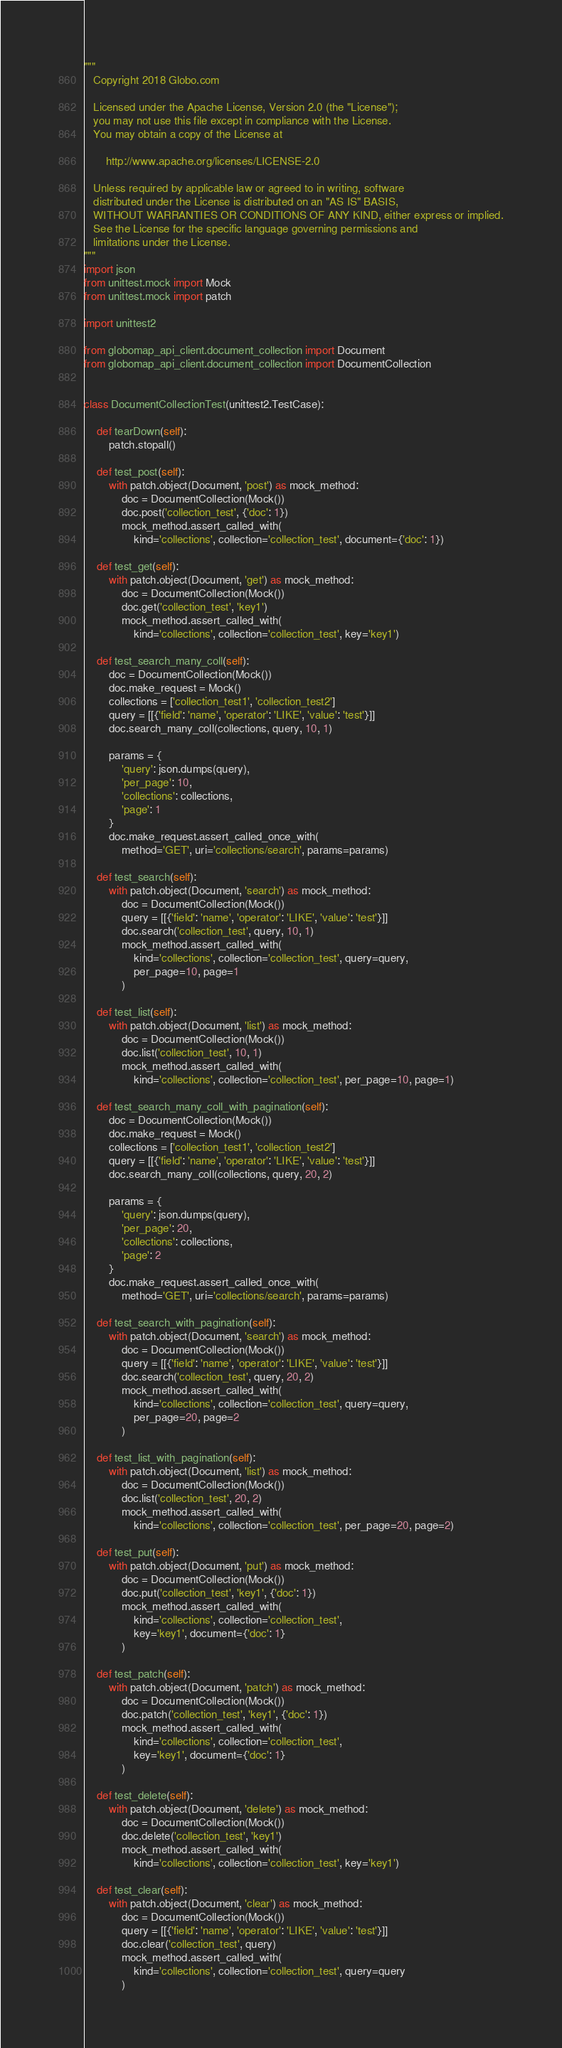Convert code to text. <code><loc_0><loc_0><loc_500><loc_500><_Python_>"""
   Copyright 2018 Globo.com

   Licensed under the Apache License, Version 2.0 (the "License");
   you may not use this file except in compliance with the License.
   You may obtain a copy of the License at

       http://www.apache.org/licenses/LICENSE-2.0

   Unless required by applicable law or agreed to in writing, software
   distributed under the License is distributed on an "AS IS" BASIS,
   WITHOUT WARRANTIES OR CONDITIONS OF ANY KIND, either express or implied.
   See the License for the specific language governing permissions and
   limitations under the License.
"""
import json
from unittest.mock import Mock
from unittest.mock import patch

import unittest2

from globomap_api_client.document_collection import Document
from globomap_api_client.document_collection import DocumentCollection


class DocumentCollectionTest(unittest2.TestCase):

    def tearDown(self):
        patch.stopall()

    def test_post(self):
        with patch.object(Document, 'post') as mock_method:
            doc = DocumentCollection(Mock())
            doc.post('collection_test', {'doc': 1})
            mock_method.assert_called_with(
                kind='collections', collection='collection_test', document={'doc': 1})

    def test_get(self):
        with patch.object(Document, 'get') as mock_method:
            doc = DocumentCollection(Mock())
            doc.get('collection_test', 'key1')
            mock_method.assert_called_with(
                kind='collections', collection='collection_test', key='key1')

    def test_search_many_coll(self):
        doc = DocumentCollection(Mock())
        doc.make_request = Mock()
        collections = ['collection_test1', 'collection_test2']
        query = [[{'field': 'name', 'operator': 'LIKE', 'value': 'test'}]]
        doc.search_many_coll(collections, query, 10, 1)

        params = {
            'query': json.dumps(query),
            'per_page': 10,
            'collections': collections,
            'page': 1
        }
        doc.make_request.assert_called_once_with(
            method='GET', uri='collections/search', params=params)

    def test_search(self):
        with patch.object(Document, 'search') as mock_method:
            doc = DocumentCollection(Mock())
            query = [[{'field': 'name', 'operator': 'LIKE', 'value': 'test'}]]
            doc.search('collection_test', query, 10, 1)
            mock_method.assert_called_with(
                kind='collections', collection='collection_test', query=query,
                per_page=10, page=1
            )

    def test_list(self):
        with patch.object(Document, 'list') as mock_method:
            doc = DocumentCollection(Mock())
            doc.list('collection_test', 10, 1)
            mock_method.assert_called_with(
                kind='collections', collection='collection_test', per_page=10, page=1)

    def test_search_many_coll_with_pagination(self):
        doc = DocumentCollection(Mock())
        doc.make_request = Mock()
        collections = ['collection_test1', 'collection_test2']
        query = [[{'field': 'name', 'operator': 'LIKE', 'value': 'test'}]]
        doc.search_many_coll(collections, query, 20, 2)

        params = {
            'query': json.dumps(query),
            'per_page': 20,
            'collections': collections,
            'page': 2
        }
        doc.make_request.assert_called_once_with(
            method='GET', uri='collections/search', params=params)

    def test_search_with_pagination(self):
        with patch.object(Document, 'search') as mock_method:
            doc = DocumentCollection(Mock())
            query = [[{'field': 'name', 'operator': 'LIKE', 'value': 'test'}]]
            doc.search('collection_test', query, 20, 2)
            mock_method.assert_called_with(
                kind='collections', collection='collection_test', query=query,
                per_page=20, page=2
            )

    def test_list_with_pagination(self):
        with patch.object(Document, 'list') as mock_method:
            doc = DocumentCollection(Mock())
            doc.list('collection_test', 20, 2)
            mock_method.assert_called_with(
                kind='collections', collection='collection_test', per_page=20, page=2)

    def test_put(self):
        with patch.object(Document, 'put') as mock_method:
            doc = DocumentCollection(Mock())
            doc.put('collection_test', 'key1', {'doc': 1})
            mock_method.assert_called_with(
                kind='collections', collection='collection_test',
                key='key1', document={'doc': 1}
            )

    def test_patch(self):
        with patch.object(Document, 'patch') as mock_method:
            doc = DocumentCollection(Mock())
            doc.patch('collection_test', 'key1', {'doc': 1})
            mock_method.assert_called_with(
                kind='collections', collection='collection_test',
                key='key1', document={'doc': 1}
            )

    def test_delete(self):
        with patch.object(Document, 'delete') as mock_method:
            doc = DocumentCollection(Mock())
            doc.delete('collection_test', 'key1')
            mock_method.assert_called_with(
                kind='collections', collection='collection_test', key='key1')

    def test_clear(self):
        with patch.object(Document, 'clear') as mock_method:
            doc = DocumentCollection(Mock())
            query = [[{'field': 'name', 'operator': 'LIKE', 'value': 'test'}]]
            doc.clear('collection_test', query)
            mock_method.assert_called_with(
                kind='collections', collection='collection_test', query=query
            )
</code> 